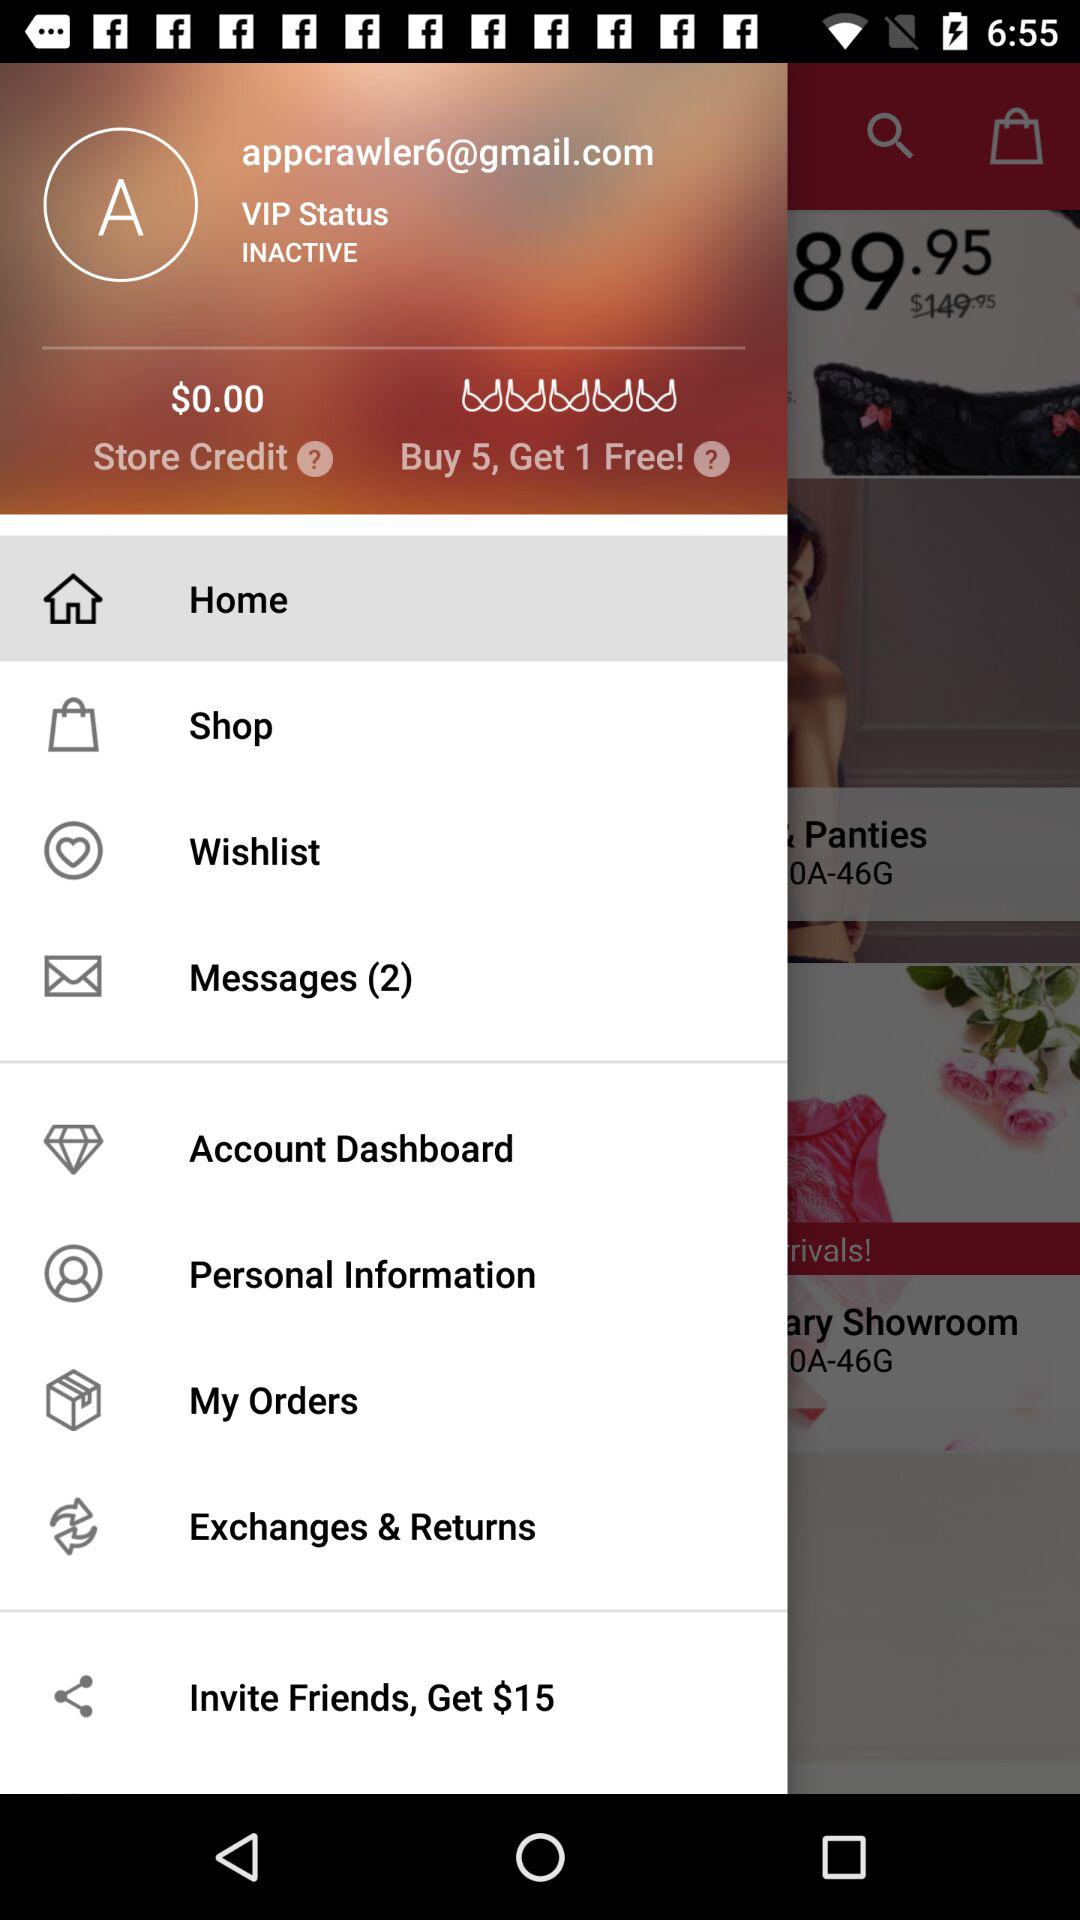What is the offer? The offer is "Buy 5, Get 1 Free!". 